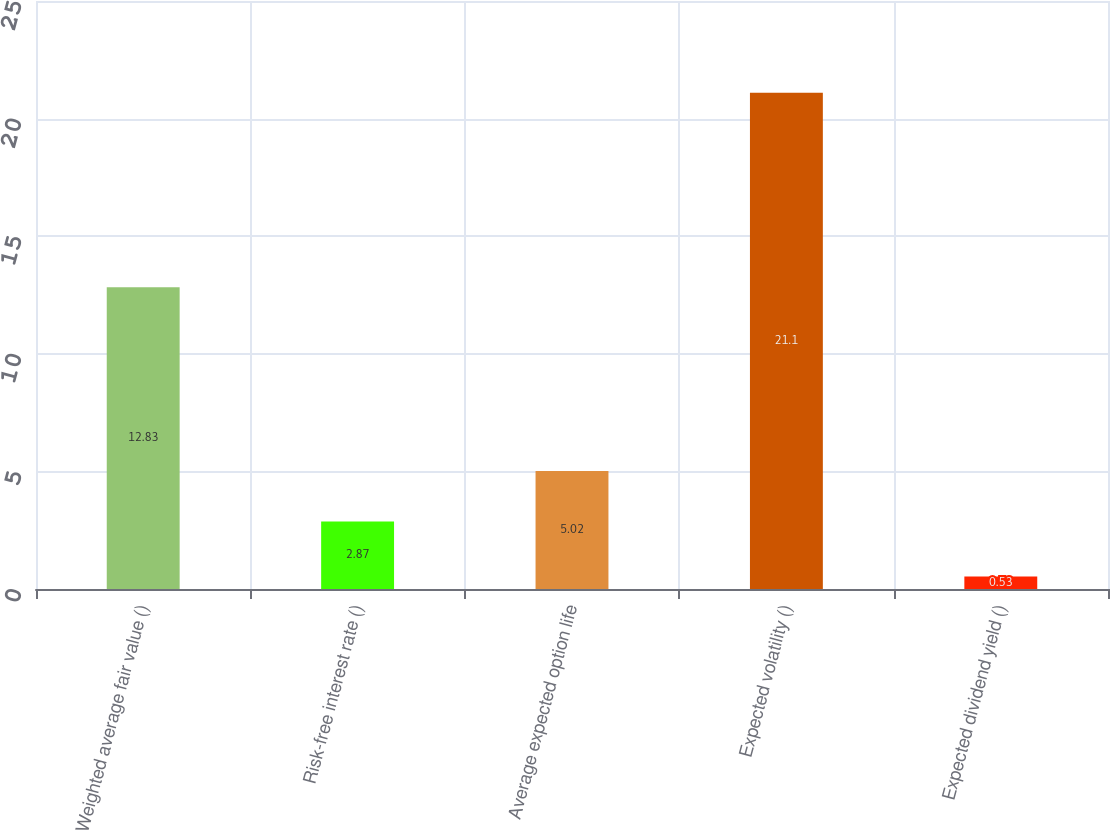Convert chart to OTSL. <chart><loc_0><loc_0><loc_500><loc_500><bar_chart><fcel>Weighted average fair value ()<fcel>Risk-free interest rate ()<fcel>Average expected option life<fcel>Expected volatility ()<fcel>Expected dividend yield ()<nl><fcel>12.83<fcel>2.87<fcel>5.02<fcel>21.1<fcel>0.53<nl></chart> 